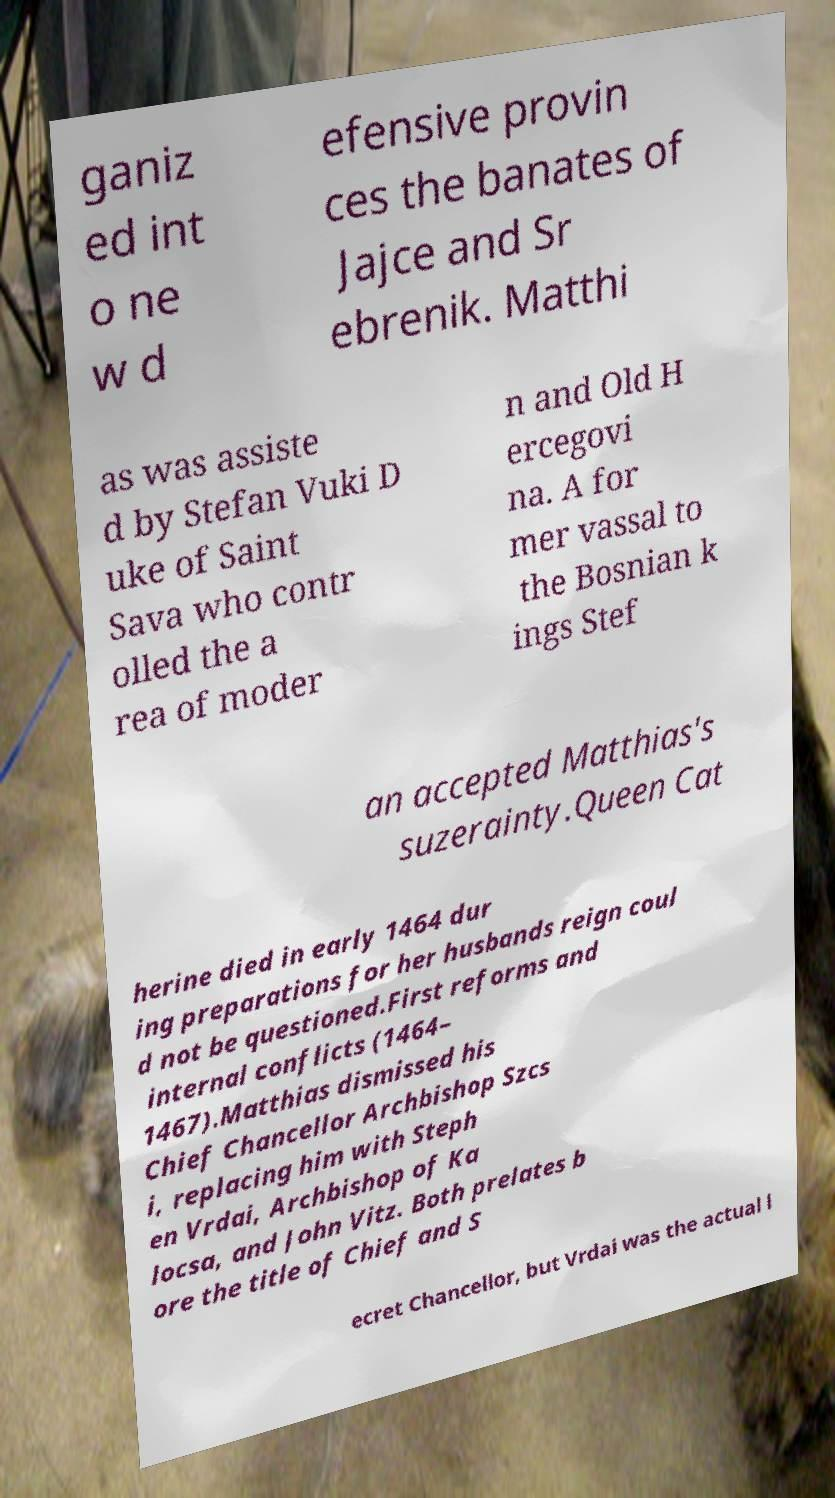For documentation purposes, I need the text within this image transcribed. Could you provide that? ganiz ed int o ne w d efensive provin ces the banates of Jajce and Sr ebrenik. Matthi as was assiste d by Stefan Vuki D uke of Saint Sava who contr olled the a rea of moder n and Old H ercegovi na. A for mer vassal to the Bosnian k ings Stef an accepted Matthias's suzerainty.Queen Cat herine died in early 1464 dur ing preparations for her husbands reign coul d not be questioned.First reforms and internal conflicts (1464– 1467).Matthias dismissed his Chief Chancellor Archbishop Szcs i, replacing him with Steph en Vrdai, Archbishop of Ka locsa, and John Vitz. Both prelates b ore the title of Chief and S ecret Chancellor, but Vrdai was the actual l 